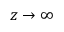<formula> <loc_0><loc_0><loc_500><loc_500>z \to \infty</formula> 